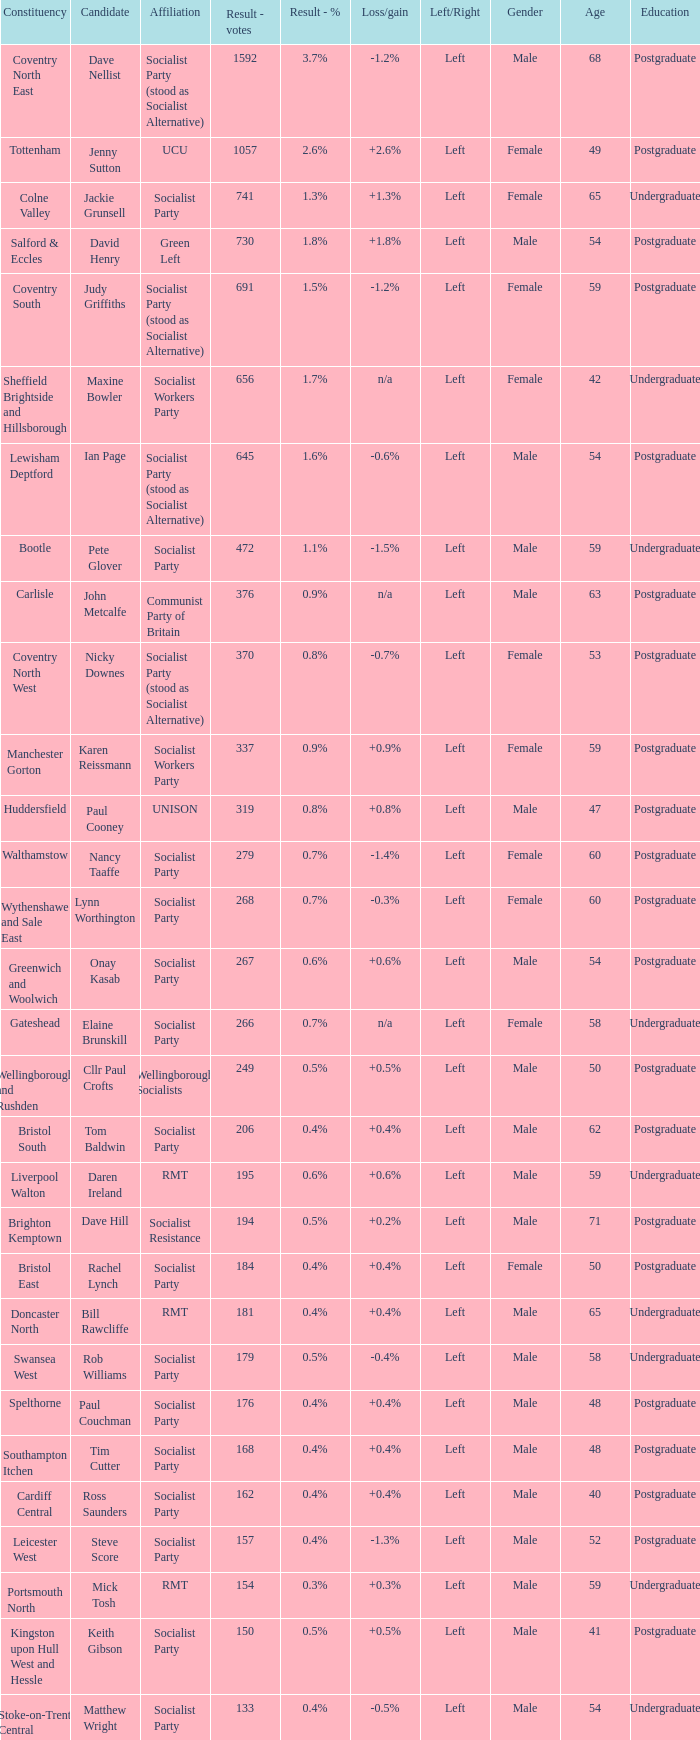What is the largest vote result if loss/gain is -0.5%? 133.0. 